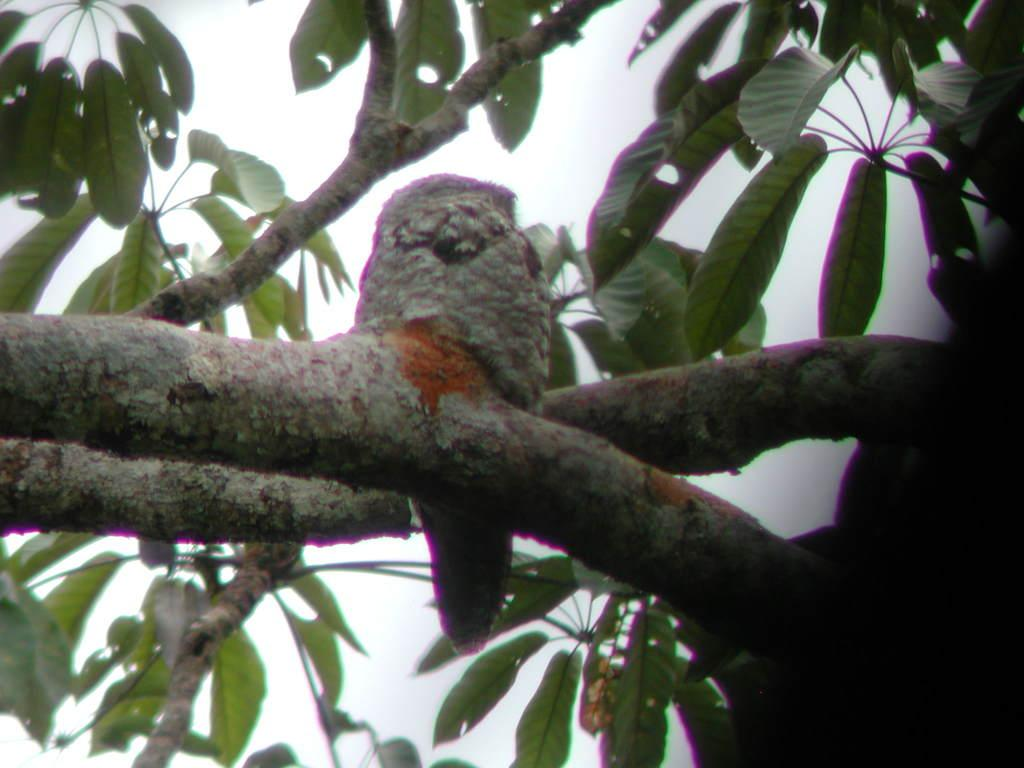What type of animal is in the image? There is a bird in the image. Where is the bird located? The bird is on a branch in the image. What is the bird sitting on? The bird is sitting on a branch of a tree in the image. What can be seen in the background of the image? The sky is visible in the background of the image. What type of lettuce is hanging from the branch in the image? There is no lettuce present in the image; it features a bird on a branch. How does the bird contribute to world peace in the image? The image does not depict the bird's role in promoting peace; it simply shows a bird on a branch. 